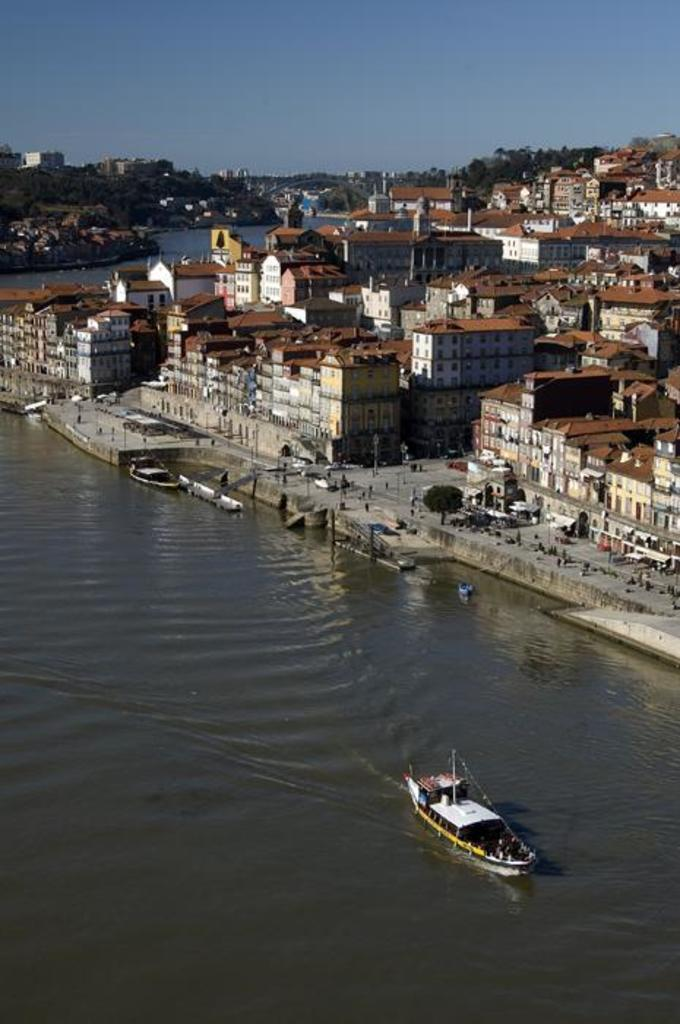What type of structures can be seen in the image? There are buildings in the image. What type of vehicles are present in the image? There are boats in the image. What are the tall, thin objects in the image? There are poles in the image. What type of vegetation is visible in the image? There are trees in the image. What body of water is present in the image? There is a river visible in the image. What part of the natural environment is visible in the image? The sky is visible in the image. What emotion is the head experiencing in the image? There is no head present in the image, so it is not possible to determine any emotions. 